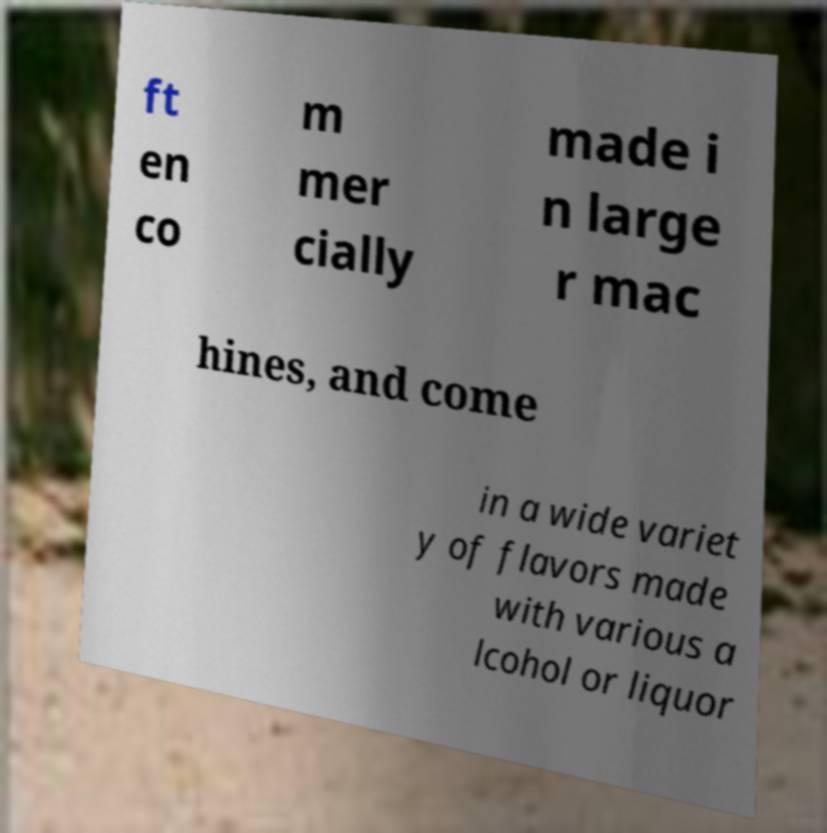There's text embedded in this image that I need extracted. Can you transcribe it verbatim? ft en co m mer cially made i n large r mac hines, and come in a wide variet y of flavors made with various a lcohol or liquor 